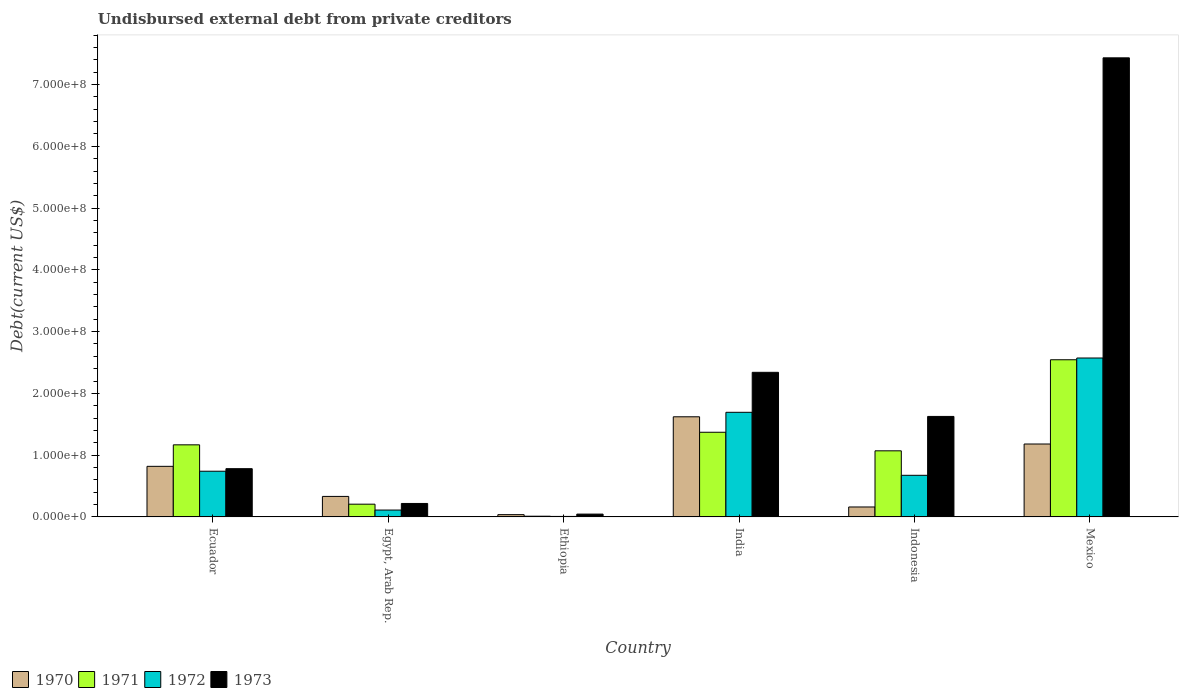How many different coloured bars are there?
Keep it short and to the point. 4. Are the number of bars per tick equal to the number of legend labels?
Your answer should be very brief. Yes. Are the number of bars on each tick of the X-axis equal?
Provide a short and direct response. Yes. How many bars are there on the 5th tick from the left?
Keep it short and to the point. 4. How many bars are there on the 2nd tick from the right?
Ensure brevity in your answer.  4. What is the label of the 2nd group of bars from the left?
Offer a terse response. Egypt, Arab Rep. What is the total debt in 1972 in Ecuador?
Ensure brevity in your answer.  7.40e+07. Across all countries, what is the maximum total debt in 1970?
Make the answer very short. 1.62e+08. Across all countries, what is the minimum total debt in 1970?
Offer a very short reply. 3.70e+06. In which country was the total debt in 1971 minimum?
Offer a terse response. Ethiopia. What is the total total debt in 1973 in the graph?
Offer a terse response. 1.24e+09. What is the difference between the total debt in 1970 in India and that in Mexico?
Your answer should be compact. 4.41e+07. What is the difference between the total debt in 1970 in Indonesia and the total debt in 1971 in Mexico?
Provide a short and direct response. -2.38e+08. What is the average total debt in 1970 per country?
Give a very brief answer. 6.92e+07. What is the difference between the total debt of/in 1972 and total debt of/in 1970 in Mexico?
Provide a succinct answer. 1.39e+08. In how many countries, is the total debt in 1973 greater than 320000000 US$?
Offer a terse response. 1. What is the ratio of the total debt in 1970 in Ecuador to that in India?
Provide a short and direct response. 0.51. Is the difference between the total debt in 1972 in Ethiopia and Mexico greater than the difference between the total debt in 1970 in Ethiopia and Mexico?
Your response must be concise. No. What is the difference between the highest and the second highest total debt in 1972?
Provide a short and direct response. 8.79e+07. What is the difference between the highest and the lowest total debt in 1973?
Ensure brevity in your answer.  7.39e+08. Is it the case that in every country, the sum of the total debt in 1972 and total debt in 1971 is greater than the sum of total debt in 1970 and total debt in 1973?
Give a very brief answer. No. What does the 3rd bar from the left in Ecuador represents?
Make the answer very short. 1972. How many bars are there?
Your answer should be very brief. 24. Are all the bars in the graph horizontal?
Ensure brevity in your answer.  No. How many countries are there in the graph?
Ensure brevity in your answer.  6. What is the difference between two consecutive major ticks on the Y-axis?
Offer a terse response. 1.00e+08. Are the values on the major ticks of Y-axis written in scientific E-notation?
Make the answer very short. Yes. What is the title of the graph?
Make the answer very short. Undisbursed external debt from private creditors. Does "1992" appear as one of the legend labels in the graph?
Provide a short and direct response. No. What is the label or title of the Y-axis?
Provide a succinct answer. Debt(current US$). What is the Debt(current US$) of 1970 in Ecuador?
Offer a very short reply. 8.19e+07. What is the Debt(current US$) of 1971 in Ecuador?
Make the answer very short. 1.17e+08. What is the Debt(current US$) in 1972 in Ecuador?
Give a very brief answer. 7.40e+07. What is the Debt(current US$) of 1973 in Ecuador?
Your answer should be very brief. 7.81e+07. What is the Debt(current US$) of 1970 in Egypt, Arab Rep.?
Provide a succinct answer. 3.32e+07. What is the Debt(current US$) of 1971 in Egypt, Arab Rep.?
Your answer should be very brief. 2.06e+07. What is the Debt(current US$) of 1972 in Egypt, Arab Rep.?
Make the answer very short. 1.11e+07. What is the Debt(current US$) of 1973 in Egypt, Arab Rep.?
Keep it short and to the point. 2.18e+07. What is the Debt(current US$) of 1970 in Ethiopia?
Your response must be concise. 3.70e+06. What is the Debt(current US$) of 1971 in Ethiopia?
Ensure brevity in your answer.  1.16e+06. What is the Debt(current US$) in 1972 in Ethiopia?
Ensure brevity in your answer.  8.20e+05. What is the Debt(current US$) in 1973 in Ethiopia?
Your response must be concise. 4.57e+06. What is the Debt(current US$) in 1970 in India?
Provide a succinct answer. 1.62e+08. What is the Debt(current US$) of 1971 in India?
Provide a short and direct response. 1.37e+08. What is the Debt(current US$) in 1972 in India?
Offer a terse response. 1.69e+08. What is the Debt(current US$) in 1973 in India?
Make the answer very short. 2.34e+08. What is the Debt(current US$) of 1970 in Indonesia?
Make the answer very short. 1.61e+07. What is the Debt(current US$) of 1971 in Indonesia?
Your answer should be compact. 1.07e+08. What is the Debt(current US$) of 1972 in Indonesia?
Ensure brevity in your answer.  6.74e+07. What is the Debt(current US$) of 1973 in Indonesia?
Give a very brief answer. 1.63e+08. What is the Debt(current US$) in 1970 in Mexico?
Ensure brevity in your answer.  1.18e+08. What is the Debt(current US$) in 1971 in Mexico?
Give a very brief answer. 2.54e+08. What is the Debt(current US$) in 1972 in Mexico?
Make the answer very short. 2.57e+08. What is the Debt(current US$) in 1973 in Mexico?
Provide a succinct answer. 7.43e+08. Across all countries, what is the maximum Debt(current US$) in 1970?
Provide a short and direct response. 1.62e+08. Across all countries, what is the maximum Debt(current US$) of 1971?
Your answer should be very brief. 2.54e+08. Across all countries, what is the maximum Debt(current US$) in 1972?
Your answer should be compact. 2.57e+08. Across all countries, what is the maximum Debt(current US$) in 1973?
Make the answer very short. 7.43e+08. Across all countries, what is the minimum Debt(current US$) in 1970?
Offer a terse response. 3.70e+06. Across all countries, what is the minimum Debt(current US$) of 1971?
Make the answer very short. 1.16e+06. Across all countries, what is the minimum Debt(current US$) of 1972?
Provide a succinct answer. 8.20e+05. Across all countries, what is the minimum Debt(current US$) in 1973?
Give a very brief answer. 4.57e+06. What is the total Debt(current US$) in 1970 in the graph?
Your response must be concise. 4.15e+08. What is the total Debt(current US$) of 1971 in the graph?
Offer a terse response. 6.37e+08. What is the total Debt(current US$) in 1972 in the graph?
Give a very brief answer. 5.80e+08. What is the total Debt(current US$) of 1973 in the graph?
Offer a very short reply. 1.24e+09. What is the difference between the Debt(current US$) of 1970 in Ecuador and that in Egypt, Arab Rep.?
Your response must be concise. 4.87e+07. What is the difference between the Debt(current US$) in 1971 in Ecuador and that in Egypt, Arab Rep.?
Give a very brief answer. 9.61e+07. What is the difference between the Debt(current US$) in 1972 in Ecuador and that in Egypt, Arab Rep.?
Offer a very short reply. 6.28e+07. What is the difference between the Debt(current US$) of 1973 in Ecuador and that in Egypt, Arab Rep.?
Your answer should be very brief. 5.63e+07. What is the difference between the Debt(current US$) of 1970 in Ecuador and that in Ethiopia?
Provide a short and direct response. 7.82e+07. What is the difference between the Debt(current US$) in 1971 in Ecuador and that in Ethiopia?
Ensure brevity in your answer.  1.16e+08. What is the difference between the Debt(current US$) of 1972 in Ecuador and that in Ethiopia?
Make the answer very short. 7.32e+07. What is the difference between the Debt(current US$) in 1973 in Ecuador and that in Ethiopia?
Ensure brevity in your answer.  7.35e+07. What is the difference between the Debt(current US$) in 1970 in Ecuador and that in India?
Offer a terse response. -8.02e+07. What is the difference between the Debt(current US$) in 1971 in Ecuador and that in India?
Keep it short and to the point. -2.03e+07. What is the difference between the Debt(current US$) in 1972 in Ecuador and that in India?
Provide a short and direct response. -9.54e+07. What is the difference between the Debt(current US$) in 1973 in Ecuador and that in India?
Offer a terse response. -1.56e+08. What is the difference between the Debt(current US$) of 1970 in Ecuador and that in Indonesia?
Make the answer very short. 6.58e+07. What is the difference between the Debt(current US$) in 1971 in Ecuador and that in Indonesia?
Ensure brevity in your answer.  9.70e+06. What is the difference between the Debt(current US$) of 1972 in Ecuador and that in Indonesia?
Provide a succinct answer. 6.60e+06. What is the difference between the Debt(current US$) in 1973 in Ecuador and that in Indonesia?
Your answer should be compact. -8.46e+07. What is the difference between the Debt(current US$) in 1970 in Ecuador and that in Mexico?
Your response must be concise. -3.62e+07. What is the difference between the Debt(current US$) in 1971 in Ecuador and that in Mexico?
Keep it short and to the point. -1.38e+08. What is the difference between the Debt(current US$) in 1972 in Ecuador and that in Mexico?
Ensure brevity in your answer.  -1.83e+08. What is the difference between the Debt(current US$) of 1973 in Ecuador and that in Mexico?
Keep it short and to the point. -6.65e+08. What is the difference between the Debt(current US$) of 1970 in Egypt, Arab Rep. and that in Ethiopia?
Offer a very short reply. 2.95e+07. What is the difference between the Debt(current US$) of 1971 in Egypt, Arab Rep. and that in Ethiopia?
Your answer should be compact. 1.95e+07. What is the difference between the Debt(current US$) of 1972 in Egypt, Arab Rep. and that in Ethiopia?
Your answer should be very brief. 1.03e+07. What is the difference between the Debt(current US$) of 1973 in Egypt, Arab Rep. and that in Ethiopia?
Make the answer very short. 1.72e+07. What is the difference between the Debt(current US$) of 1970 in Egypt, Arab Rep. and that in India?
Give a very brief answer. -1.29e+08. What is the difference between the Debt(current US$) in 1971 in Egypt, Arab Rep. and that in India?
Offer a very short reply. -1.16e+08. What is the difference between the Debt(current US$) in 1972 in Egypt, Arab Rep. and that in India?
Ensure brevity in your answer.  -1.58e+08. What is the difference between the Debt(current US$) of 1973 in Egypt, Arab Rep. and that in India?
Provide a succinct answer. -2.12e+08. What is the difference between the Debt(current US$) of 1970 in Egypt, Arab Rep. and that in Indonesia?
Ensure brevity in your answer.  1.71e+07. What is the difference between the Debt(current US$) in 1971 in Egypt, Arab Rep. and that in Indonesia?
Your response must be concise. -8.64e+07. What is the difference between the Debt(current US$) in 1972 in Egypt, Arab Rep. and that in Indonesia?
Ensure brevity in your answer.  -5.62e+07. What is the difference between the Debt(current US$) in 1973 in Egypt, Arab Rep. and that in Indonesia?
Your response must be concise. -1.41e+08. What is the difference between the Debt(current US$) in 1970 in Egypt, Arab Rep. and that in Mexico?
Give a very brief answer. -8.48e+07. What is the difference between the Debt(current US$) of 1971 in Egypt, Arab Rep. and that in Mexico?
Your answer should be very brief. -2.34e+08. What is the difference between the Debt(current US$) in 1972 in Egypt, Arab Rep. and that in Mexico?
Your answer should be compact. -2.46e+08. What is the difference between the Debt(current US$) in 1973 in Egypt, Arab Rep. and that in Mexico?
Provide a succinct answer. -7.21e+08. What is the difference between the Debt(current US$) in 1970 in Ethiopia and that in India?
Your answer should be compact. -1.58e+08. What is the difference between the Debt(current US$) of 1971 in Ethiopia and that in India?
Offer a terse response. -1.36e+08. What is the difference between the Debt(current US$) in 1972 in Ethiopia and that in India?
Your answer should be compact. -1.69e+08. What is the difference between the Debt(current US$) of 1973 in Ethiopia and that in India?
Provide a short and direct response. -2.30e+08. What is the difference between the Debt(current US$) in 1970 in Ethiopia and that in Indonesia?
Keep it short and to the point. -1.24e+07. What is the difference between the Debt(current US$) of 1971 in Ethiopia and that in Indonesia?
Your answer should be compact. -1.06e+08. What is the difference between the Debt(current US$) of 1972 in Ethiopia and that in Indonesia?
Keep it short and to the point. -6.66e+07. What is the difference between the Debt(current US$) of 1973 in Ethiopia and that in Indonesia?
Make the answer very short. -1.58e+08. What is the difference between the Debt(current US$) in 1970 in Ethiopia and that in Mexico?
Offer a terse response. -1.14e+08. What is the difference between the Debt(current US$) of 1971 in Ethiopia and that in Mexico?
Make the answer very short. -2.53e+08. What is the difference between the Debt(current US$) in 1972 in Ethiopia and that in Mexico?
Ensure brevity in your answer.  -2.56e+08. What is the difference between the Debt(current US$) in 1973 in Ethiopia and that in Mexico?
Make the answer very short. -7.39e+08. What is the difference between the Debt(current US$) in 1970 in India and that in Indonesia?
Offer a terse response. 1.46e+08. What is the difference between the Debt(current US$) in 1971 in India and that in Indonesia?
Your answer should be very brief. 3.00e+07. What is the difference between the Debt(current US$) of 1972 in India and that in Indonesia?
Provide a succinct answer. 1.02e+08. What is the difference between the Debt(current US$) of 1973 in India and that in Indonesia?
Your answer should be very brief. 7.14e+07. What is the difference between the Debt(current US$) of 1970 in India and that in Mexico?
Give a very brief answer. 4.41e+07. What is the difference between the Debt(current US$) of 1971 in India and that in Mexico?
Give a very brief answer. -1.17e+08. What is the difference between the Debt(current US$) in 1972 in India and that in Mexico?
Keep it short and to the point. -8.79e+07. What is the difference between the Debt(current US$) of 1973 in India and that in Mexico?
Offer a terse response. -5.09e+08. What is the difference between the Debt(current US$) in 1970 in Indonesia and that in Mexico?
Your response must be concise. -1.02e+08. What is the difference between the Debt(current US$) of 1971 in Indonesia and that in Mexico?
Provide a short and direct response. -1.47e+08. What is the difference between the Debt(current US$) in 1972 in Indonesia and that in Mexico?
Make the answer very short. -1.90e+08. What is the difference between the Debt(current US$) in 1973 in Indonesia and that in Mexico?
Provide a short and direct response. -5.81e+08. What is the difference between the Debt(current US$) in 1970 in Ecuador and the Debt(current US$) in 1971 in Egypt, Arab Rep.?
Provide a short and direct response. 6.13e+07. What is the difference between the Debt(current US$) of 1970 in Ecuador and the Debt(current US$) of 1972 in Egypt, Arab Rep.?
Provide a short and direct response. 7.08e+07. What is the difference between the Debt(current US$) in 1970 in Ecuador and the Debt(current US$) in 1973 in Egypt, Arab Rep.?
Provide a succinct answer. 6.01e+07. What is the difference between the Debt(current US$) of 1971 in Ecuador and the Debt(current US$) of 1972 in Egypt, Arab Rep.?
Keep it short and to the point. 1.06e+08. What is the difference between the Debt(current US$) of 1971 in Ecuador and the Debt(current US$) of 1973 in Egypt, Arab Rep.?
Give a very brief answer. 9.49e+07. What is the difference between the Debt(current US$) in 1972 in Ecuador and the Debt(current US$) in 1973 in Egypt, Arab Rep.?
Your answer should be compact. 5.22e+07. What is the difference between the Debt(current US$) in 1970 in Ecuador and the Debt(current US$) in 1971 in Ethiopia?
Offer a terse response. 8.07e+07. What is the difference between the Debt(current US$) of 1970 in Ecuador and the Debt(current US$) of 1972 in Ethiopia?
Offer a terse response. 8.11e+07. What is the difference between the Debt(current US$) of 1970 in Ecuador and the Debt(current US$) of 1973 in Ethiopia?
Provide a short and direct response. 7.73e+07. What is the difference between the Debt(current US$) of 1971 in Ecuador and the Debt(current US$) of 1972 in Ethiopia?
Make the answer very short. 1.16e+08. What is the difference between the Debt(current US$) of 1971 in Ecuador and the Debt(current US$) of 1973 in Ethiopia?
Provide a succinct answer. 1.12e+08. What is the difference between the Debt(current US$) in 1972 in Ecuador and the Debt(current US$) in 1973 in Ethiopia?
Provide a succinct answer. 6.94e+07. What is the difference between the Debt(current US$) in 1970 in Ecuador and the Debt(current US$) in 1971 in India?
Your response must be concise. -5.52e+07. What is the difference between the Debt(current US$) in 1970 in Ecuador and the Debt(current US$) in 1972 in India?
Provide a succinct answer. -8.75e+07. What is the difference between the Debt(current US$) in 1970 in Ecuador and the Debt(current US$) in 1973 in India?
Your response must be concise. -1.52e+08. What is the difference between the Debt(current US$) in 1971 in Ecuador and the Debt(current US$) in 1972 in India?
Provide a short and direct response. -5.27e+07. What is the difference between the Debt(current US$) of 1971 in Ecuador and the Debt(current US$) of 1973 in India?
Offer a very short reply. -1.17e+08. What is the difference between the Debt(current US$) of 1972 in Ecuador and the Debt(current US$) of 1973 in India?
Offer a very short reply. -1.60e+08. What is the difference between the Debt(current US$) in 1970 in Ecuador and the Debt(current US$) in 1971 in Indonesia?
Your answer should be compact. -2.51e+07. What is the difference between the Debt(current US$) of 1970 in Ecuador and the Debt(current US$) of 1972 in Indonesia?
Your answer should be very brief. 1.45e+07. What is the difference between the Debt(current US$) in 1970 in Ecuador and the Debt(current US$) in 1973 in Indonesia?
Give a very brief answer. -8.08e+07. What is the difference between the Debt(current US$) of 1971 in Ecuador and the Debt(current US$) of 1972 in Indonesia?
Keep it short and to the point. 4.93e+07. What is the difference between the Debt(current US$) of 1971 in Ecuador and the Debt(current US$) of 1973 in Indonesia?
Give a very brief answer. -4.60e+07. What is the difference between the Debt(current US$) in 1972 in Ecuador and the Debt(current US$) in 1973 in Indonesia?
Offer a terse response. -8.87e+07. What is the difference between the Debt(current US$) of 1970 in Ecuador and the Debt(current US$) of 1971 in Mexico?
Keep it short and to the point. -1.73e+08. What is the difference between the Debt(current US$) of 1970 in Ecuador and the Debt(current US$) of 1972 in Mexico?
Make the answer very short. -1.75e+08. What is the difference between the Debt(current US$) of 1970 in Ecuador and the Debt(current US$) of 1973 in Mexico?
Offer a terse response. -6.61e+08. What is the difference between the Debt(current US$) in 1971 in Ecuador and the Debt(current US$) in 1972 in Mexico?
Offer a very short reply. -1.41e+08. What is the difference between the Debt(current US$) of 1971 in Ecuador and the Debt(current US$) of 1973 in Mexico?
Provide a short and direct response. -6.27e+08. What is the difference between the Debt(current US$) of 1972 in Ecuador and the Debt(current US$) of 1973 in Mexico?
Give a very brief answer. -6.69e+08. What is the difference between the Debt(current US$) in 1970 in Egypt, Arab Rep. and the Debt(current US$) in 1971 in Ethiopia?
Offer a terse response. 3.21e+07. What is the difference between the Debt(current US$) of 1970 in Egypt, Arab Rep. and the Debt(current US$) of 1972 in Ethiopia?
Provide a succinct answer. 3.24e+07. What is the difference between the Debt(current US$) in 1970 in Egypt, Arab Rep. and the Debt(current US$) in 1973 in Ethiopia?
Keep it short and to the point. 2.87e+07. What is the difference between the Debt(current US$) in 1971 in Egypt, Arab Rep. and the Debt(current US$) in 1972 in Ethiopia?
Your response must be concise. 1.98e+07. What is the difference between the Debt(current US$) of 1971 in Egypt, Arab Rep. and the Debt(current US$) of 1973 in Ethiopia?
Offer a terse response. 1.61e+07. What is the difference between the Debt(current US$) in 1972 in Egypt, Arab Rep. and the Debt(current US$) in 1973 in Ethiopia?
Give a very brief answer. 6.56e+06. What is the difference between the Debt(current US$) of 1970 in Egypt, Arab Rep. and the Debt(current US$) of 1971 in India?
Your answer should be very brief. -1.04e+08. What is the difference between the Debt(current US$) in 1970 in Egypt, Arab Rep. and the Debt(current US$) in 1972 in India?
Your answer should be very brief. -1.36e+08. What is the difference between the Debt(current US$) in 1970 in Egypt, Arab Rep. and the Debt(current US$) in 1973 in India?
Give a very brief answer. -2.01e+08. What is the difference between the Debt(current US$) of 1971 in Egypt, Arab Rep. and the Debt(current US$) of 1972 in India?
Keep it short and to the point. -1.49e+08. What is the difference between the Debt(current US$) of 1971 in Egypt, Arab Rep. and the Debt(current US$) of 1973 in India?
Keep it short and to the point. -2.13e+08. What is the difference between the Debt(current US$) in 1972 in Egypt, Arab Rep. and the Debt(current US$) in 1973 in India?
Ensure brevity in your answer.  -2.23e+08. What is the difference between the Debt(current US$) of 1970 in Egypt, Arab Rep. and the Debt(current US$) of 1971 in Indonesia?
Your answer should be compact. -7.38e+07. What is the difference between the Debt(current US$) of 1970 in Egypt, Arab Rep. and the Debt(current US$) of 1972 in Indonesia?
Your response must be concise. -3.42e+07. What is the difference between the Debt(current US$) of 1970 in Egypt, Arab Rep. and the Debt(current US$) of 1973 in Indonesia?
Keep it short and to the point. -1.29e+08. What is the difference between the Debt(current US$) in 1971 in Egypt, Arab Rep. and the Debt(current US$) in 1972 in Indonesia?
Your answer should be compact. -4.67e+07. What is the difference between the Debt(current US$) in 1971 in Egypt, Arab Rep. and the Debt(current US$) in 1973 in Indonesia?
Keep it short and to the point. -1.42e+08. What is the difference between the Debt(current US$) of 1972 in Egypt, Arab Rep. and the Debt(current US$) of 1973 in Indonesia?
Keep it short and to the point. -1.52e+08. What is the difference between the Debt(current US$) in 1970 in Egypt, Arab Rep. and the Debt(current US$) in 1971 in Mexico?
Your response must be concise. -2.21e+08. What is the difference between the Debt(current US$) of 1970 in Egypt, Arab Rep. and the Debt(current US$) of 1972 in Mexico?
Provide a short and direct response. -2.24e+08. What is the difference between the Debt(current US$) of 1970 in Egypt, Arab Rep. and the Debt(current US$) of 1973 in Mexico?
Provide a short and direct response. -7.10e+08. What is the difference between the Debt(current US$) of 1971 in Egypt, Arab Rep. and the Debt(current US$) of 1972 in Mexico?
Make the answer very short. -2.37e+08. What is the difference between the Debt(current US$) in 1971 in Egypt, Arab Rep. and the Debt(current US$) in 1973 in Mexico?
Give a very brief answer. -7.23e+08. What is the difference between the Debt(current US$) of 1972 in Egypt, Arab Rep. and the Debt(current US$) of 1973 in Mexico?
Give a very brief answer. -7.32e+08. What is the difference between the Debt(current US$) of 1970 in Ethiopia and the Debt(current US$) of 1971 in India?
Provide a short and direct response. -1.33e+08. What is the difference between the Debt(current US$) of 1970 in Ethiopia and the Debt(current US$) of 1972 in India?
Make the answer very short. -1.66e+08. What is the difference between the Debt(current US$) of 1970 in Ethiopia and the Debt(current US$) of 1973 in India?
Offer a terse response. -2.30e+08. What is the difference between the Debt(current US$) of 1971 in Ethiopia and the Debt(current US$) of 1972 in India?
Give a very brief answer. -1.68e+08. What is the difference between the Debt(current US$) of 1971 in Ethiopia and the Debt(current US$) of 1973 in India?
Your answer should be compact. -2.33e+08. What is the difference between the Debt(current US$) of 1972 in Ethiopia and the Debt(current US$) of 1973 in India?
Make the answer very short. -2.33e+08. What is the difference between the Debt(current US$) of 1970 in Ethiopia and the Debt(current US$) of 1971 in Indonesia?
Give a very brief answer. -1.03e+08. What is the difference between the Debt(current US$) of 1970 in Ethiopia and the Debt(current US$) of 1972 in Indonesia?
Keep it short and to the point. -6.37e+07. What is the difference between the Debt(current US$) in 1970 in Ethiopia and the Debt(current US$) in 1973 in Indonesia?
Your answer should be very brief. -1.59e+08. What is the difference between the Debt(current US$) of 1971 in Ethiopia and the Debt(current US$) of 1972 in Indonesia?
Your answer should be compact. -6.62e+07. What is the difference between the Debt(current US$) of 1971 in Ethiopia and the Debt(current US$) of 1973 in Indonesia?
Ensure brevity in your answer.  -1.62e+08. What is the difference between the Debt(current US$) of 1972 in Ethiopia and the Debt(current US$) of 1973 in Indonesia?
Ensure brevity in your answer.  -1.62e+08. What is the difference between the Debt(current US$) of 1970 in Ethiopia and the Debt(current US$) of 1971 in Mexico?
Keep it short and to the point. -2.51e+08. What is the difference between the Debt(current US$) in 1970 in Ethiopia and the Debt(current US$) in 1972 in Mexico?
Offer a terse response. -2.54e+08. What is the difference between the Debt(current US$) in 1970 in Ethiopia and the Debt(current US$) in 1973 in Mexico?
Your answer should be very brief. -7.40e+08. What is the difference between the Debt(current US$) of 1971 in Ethiopia and the Debt(current US$) of 1972 in Mexico?
Ensure brevity in your answer.  -2.56e+08. What is the difference between the Debt(current US$) in 1971 in Ethiopia and the Debt(current US$) in 1973 in Mexico?
Make the answer very short. -7.42e+08. What is the difference between the Debt(current US$) of 1972 in Ethiopia and the Debt(current US$) of 1973 in Mexico?
Provide a succinct answer. -7.42e+08. What is the difference between the Debt(current US$) of 1970 in India and the Debt(current US$) of 1971 in Indonesia?
Provide a short and direct response. 5.51e+07. What is the difference between the Debt(current US$) of 1970 in India and the Debt(current US$) of 1972 in Indonesia?
Ensure brevity in your answer.  9.47e+07. What is the difference between the Debt(current US$) of 1970 in India and the Debt(current US$) of 1973 in Indonesia?
Offer a very short reply. -5.84e+05. What is the difference between the Debt(current US$) in 1971 in India and the Debt(current US$) in 1972 in Indonesia?
Offer a very short reply. 6.97e+07. What is the difference between the Debt(current US$) of 1971 in India and the Debt(current US$) of 1973 in Indonesia?
Make the answer very short. -2.56e+07. What is the difference between the Debt(current US$) in 1972 in India and the Debt(current US$) in 1973 in Indonesia?
Make the answer very short. 6.68e+06. What is the difference between the Debt(current US$) of 1970 in India and the Debt(current US$) of 1971 in Mexico?
Provide a succinct answer. -9.23e+07. What is the difference between the Debt(current US$) in 1970 in India and the Debt(current US$) in 1972 in Mexico?
Provide a short and direct response. -9.51e+07. What is the difference between the Debt(current US$) of 1970 in India and the Debt(current US$) of 1973 in Mexico?
Ensure brevity in your answer.  -5.81e+08. What is the difference between the Debt(current US$) of 1971 in India and the Debt(current US$) of 1972 in Mexico?
Provide a short and direct response. -1.20e+08. What is the difference between the Debt(current US$) of 1971 in India and the Debt(current US$) of 1973 in Mexico?
Your answer should be very brief. -6.06e+08. What is the difference between the Debt(current US$) in 1972 in India and the Debt(current US$) in 1973 in Mexico?
Your answer should be compact. -5.74e+08. What is the difference between the Debt(current US$) of 1970 in Indonesia and the Debt(current US$) of 1971 in Mexico?
Provide a succinct answer. -2.38e+08. What is the difference between the Debt(current US$) of 1970 in Indonesia and the Debt(current US$) of 1972 in Mexico?
Give a very brief answer. -2.41e+08. What is the difference between the Debt(current US$) of 1970 in Indonesia and the Debt(current US$) of 1973 in Mexico?
Offer a very short reply. -7.27e+08. What is the difference between the Debt(current US$) of 1971 in Indonesia and the Debt(current US$) of 1972 in Mexico?
Provide a succinct answer. -1.50e+08. What is the difference between the Debt(current US$) in 1971 in Indonesia and the Debt(current US$) in 1973 in Mexico?
Your response must be concise. -6.36e+08. What is the difference between the Debt(current US$) of 1972 in Indonesia and the Debt(current US$) of 1973 in Mexico?
Ensure brevity in your answer.  -6.76e+08. What is the average Debt(current US$) of 1970 per country?
Offer a very short reply. 6.92e+07. What is the average Debt(current US$) in 1971 per country?
Your answer should be very brief. 1.06e+08. What is the average Debt(current US$) of 1972 per country?
Offer a very short reply. 9.67e+07. What is the average Debt(current US$) of 1973 per country?
Give a very brief answer. 2.07e+08. What is the difference between the Debt(current US$) of 1970 and Debt(current US$) of 1971 in Ecuador?
Your response must be concise. -3.48e+07. What is the difference between the Debt(current US$) of 1970 and Debt(current US$) of 1972 in Ecuador?
Your response must be concise. 7.92e+06. What is the difference between the Debt(current US$) of 1970 and Debt(current US$) of 1973 in Ecuador?
Provide a short and direct response. 3.78e+06. What is the difference between the Debt(current US$) of 1971 and Debt(current US$) of 1972 in Ecuador?
Offer a very short reply. 4.27e+07. What is the difference between the Debt(current US$) of 1971 and Debt(current US$) of 1973 in Ecuador?
Your response must be concise. 3.86e+07. What is the difference between the Debt(current US$) in 1972 and Debt(current US$) in 1973 in Ecuador?
Make the answer very short. -4.14e+06. What is the difference between the Debt(current US$) in 1970 and Debt(current US$) in 1971 in Egypt, Arab Rep.?
Offer a very short reply. 1.26e+07. What is the difference between the Debt(current US$) of 1970 and Debt(current US$) of 1972 in Egypt, Arab Rep.?
Offer a terse response. 2.21e+07. What is the difference between the Debt(current US$) of 1970 and Debt(current US$) of 1973 in Egypt, Arab Rep.?
Offer a terse response. 1.14e+07. What is the difference between the Debt(current US$) in 1971 and Debt(current US$) in 1972 in Egypt, Arab Rep.?
Keep it short and to the point. 9.50e+06. What is the difference between the Debt(current US$) of 1971 and Debt(current US$) of 1973 in Egypt, Arab Rep.?
Keep it short and to the point. -1.17e+06. What is the difference between the Debt(current US$) of 1972 and Debt(current US$) of 1973 in Egypt, Arab Rep.?
Your answer should be compact. -1.07e+07. What is the difference between the Debt(current US$) in 1970 and Debt(current US$) in 1971 in Ethiopia?
Your answer should be very brief. 2.53e+06. What is the difference between the Debt(current US$) in 1970 and Debt(current US$) in 1972 in Ethiopia?
Provide a succinct answer. 2.88e+06. What is the difference between the Debt(current US$) in 1970 and Debt(current US$) in 1973 in Ethiopia?
Make the answer very short. -8.70e+05. What is the difference between the Debt(current US$) in 1971 and Debt(current US$) in 1972 in Ethiopia?
Your answer should be very brief. 3.45e+05. What is the difference between the Debt(current US$) in 1971 and Debt(current US$) in 1973 in Ethiopia?
Give a very brief answer. -3.40e+06. What is the difference between the Debt(current US$) of 1972 and Debt(current US$) of 1973 in Ethiopia?
Keep it short and to the point. -3.75e+06. What is the difference between the Debt(current US$) in 1970 and Debt(current US$) in 1971 in India?
Your answer should be very brief. 2.51e+07. What is the difference between the Debt(current US$) of 1970 and Debt(current US$) of 1972 in India?
Ensure brevity in your answer.  -7.26e+06. What is the difference between the Debt(current US$) of 1970 and Debt(current US$) of 1973 in India?
Ensure brevity in your answer.  -7.20e+07. What is the difference between the Debt(current US$) of 1971 and Debt(current US$) of 1972 in India?
Give a very brief answer. -3.23e+07. What is the difference between the Debt(current US$) in 1971 and Debt(current US$) in 1973 in India?
Your response must be concise. -9.70e+07. What is the difference between the Debt(current US$) of 1972 and Debt(current US$) of 1973 in India?
Ensure brevity in your answer.  -6.47e+07. What is the difference between the Debt(current US$) of 1970 and Debt(current US$) of 1971 in Indonesia?
Your response must be concise. -9.09e+07. What is the difference between the Debt(current US$) in 1970 and Debt(current US$) in 1972 in Indonesia?
Your response must be concise. -5.12e+07. What is the difference between the Debt(current US$) in 1970 and Debt(current US$) in 1973 in Indonesia?
Your response must be concise. -1.47e+08. What is the difference between the Debt(current US$) in 1971 and Debt(current US$) in 1972 in Indonesia?
Offer a very short reply. 3.96e+07. What is the difference between the Debt(current US$) of 1971 and Debt(current US$) of 1973 in Indonesia?
Provide a succinct answer. -5.57e+07. What is the difference between the Debt(current US$) of 1972 and Debt(current US$) of 1973 in Indonesia?
Your answer should be compact. -9.53e+07. What is the difference between the Debt(current US$) in 1970 and Debt(current US$) in 1971 in Mexico?
Offer a very short reply. -1.36e+08. What is the difference between the Debt(current US$) in 1970 and Debt(current US$) in 1972 in Mexico?
Keep it short and to the point. -1.39e+08. What is the difference between the Debt(current US$) in 1970 and Debt(current US$) in 1973 in Mexico?
Provide a short and direct response. -6.25e+08. What is the difference between the Debt(current US$) in 1971 and Debt(current US$) in 1972 in Mexico?
Your response must be concise. -2.84e+06. What is the difference between the Debt(current US$) in 1971 and Debt(current US$) in 1973 in Mexico?
Make the answer very short. -4.89e+08. What is the difference between the Debt(current US$) in 1972 and Debt(current US$) in 1973 in Mexico?
Your answer should be very brief. -4.86e+08. What is the ratio of the Debt(current US$) of 1970 in Ecuador to that in Egypt, Arab Rep.?
Your answer should be very brief. 2.47. What is the ratio of the Debt(current US$) in 1971 in Ecuador to that in Egypt, Arab Rep.?
Your response must be concise. 5.66. What is the ratio of the Debt(current US$) of 1972 in Ecuador to that in Egypt, Arab Rep.?
Offer a terse response. 6.65. What is the ratio of the Debt(current US$) in 1973 in Ecuador to that in Egypt, Arab Rep.?
Offer a terse response. 3.58. What is the ratio of the Debt(current US$) in 1970 in Ecuador to that in Ethiopia?
Offer a very short reply. 22.15. What is the ratio of the Debt(current US$) in 1971 in Ecuador to that in Ethiopia?
Offer a terse response. 100.19. What is the ratio of the Debt(current US$) of 1972 in Ecuador to that in Ethiopia?
Provide a short and direct response. 90.21. What is the ratio of the Debt(current US$) in 1973 in Ecuador to that in Ethiopia?
Offer a terse response. 17.1. What is the ratio of the Debt(current US$) in 1970 in Ecuador to that in India?
Offer a terse response. 0.51. What is the ratio of the Debt(current US$) in 1971 in Ecuador to that in India?
Make the answer very short. 0.85. What is the ratio of the Debt(current US$) of 1972 in Ecuador to that in India?
Give a very brief answer. 0.44. What is the ratio of the Debt(current US$) of 1973 in Ecuador to that in India?
Ensure brevity in your answer.  0.33. What is the ratio of the Debt(current US$) in 1970 in Ecuador to that in Indonesia?
Provide a succinct answer. 5.08. What is the ratio of the Debt(current US$) of 1971 in Ecuador to that in Indonesia?
Ensure brevity in your answer.  1.09. What is the ratio of the Debt(current US$) of 1972 in Ecuador to that in Indonesia?
Your answer should be very brief. 1.1. What is the ratio of the Debt(current US$) in 1973 in Ecuador to that in Indonesia?
Offer a terse response. 0.48. What is the ratio of the Debt(current US$) of 1970 in Ecuador to that in Mexico?
Offer a very short reply. 0.69. What is the ratio of the Debt(current US$) in 1971 in Ecuador to that in Mexico?
Offer a terse response. 0.46. What is the ratio of the Debt(current US$) in 1972 in Ecuador to that in Mexico?
Give a very brief answer. 0.29. What is the ratio of the Debt(current US$) of 1973 in Ecuador to that in Mexico?
Offer a very short reply. 0.11. What is the ratio of the Debt(current US$) in 1970 in Egypt, Arab Rep. to that in Ethiopia?
Make the answer very short. 8.99. What is the ratio of the Debt(current US$) in 1971 in Egypt, Arab Rep. to that in Ethiopia?
Give a very brief answer. 17.71. What is the ratio of the Debt(current US$) of 1972 in Egypt, Arab Rep. to that in Ethiopia?
Keep it short and to the point. 13.57. What is the ratio of the Debt(current US$) of 1973 in Egypt, Arab Rep. to that in Ethiopia?
Keep it short and to the point. 4.77. What is the ratio of the Debt(current US$) in 1970 in Egypt, Arab Rep. to that in India?
Offer a terse response. 0.2. What is the ratio of the Debt(current US$) in 1971 in Egypt, Arab Rep. to that in India?
Offer a very short reply. 0.15. What is the ratio of the Debt(current US$) in 1972 in Egypt, Arab Rep. to that in India?
Offer a very short reply. 0.07. What is the ratio of the Debt(current US$) of 1973 in Egypt, Arab Rep. to that in India?
Offer a terse response. 0.09. What is the ratio of the Debt(current US$) in 1970 in Egypt, Arab Rep. to that in Indonesia?
Offer a terse response. 2.06. What is the ratio of the Debt(current US$) of 1971 in Egypt, Arab Rep. to that in Indonesia?
Your response must be concise. 0.19. What is the ratio of the Debt(current US$) in 1972 in Egypt, Arab Rep. to that in Indonesia?
Ensure brevity in your answer.  0.17. What is the ratio of the Debt(current US$) in 1973 in Egypt, Arab Rep. to that in Indonesia?
Offer a very short reply. 0.13. What is the ratio of the Debt(current US$) of 1970 in Egypt, Arab Rep. to that in Mexico?
Keep it short and to the point. 0.28. What is the ratio of the Debt(current US$) of 1971 in Egypt, Arab Rep. to that in Mexico?
Provide a short and direct response. 0.08. What is the ratio of the Debt(current US$) in 1972 in Egypt, Arab Rep. to that in Mexico?
Ensure brevity in your answer.  0.04. What is the ratio of the Debt(current US$) of 1973 in Egypt, Arab Rep. to that in Mexico?
Offer a terse response. 0.03. What is the ratio of the Debt(current US$) in 1970 in Ethiopia to that in India?
Ensure brevity in your answer.  0.02. What is the ratio of the Debt(current US$) of 1971 in Ethiopia to that in India?
Offer a very short reply. 0.01. What is the ratio of the Debt(current US$) of 1972 in Ethiopia to that in India?
Give a very brief answer. 0. What is the ratio of the Debt(current US$) of 1973 in Ethiopia to that in India?
Offer a very short reply. 0.02. What is the ratio of the Debt(current US$) in 1970 in Ethiopia to that in Indonesia?
Make the answer very short. 0.23. What is the ratio of the Debt(current US$) of 1971 in Ethiopia to that in Indonesia?
Provide a succinct answer. 0.01. What is the ratio of the Debt(current US$) of 1972 in Ethiopia to that in Indonesia?
Ensure brevity in your answer.  0.01. What is the ratio of the Debt(current US$) in 1973 in Ethiopia to that in Indonesia?
Your answer should be very brief. 0.03. What is the ratio of the Debt(current US$) of 1970 in Ethiopia to that in Mexico?
Your answer should be compact. 0.03. What is the ratio of the Debt(current US$) in 1971 in Ethiopia to that in Mexico?
Offer a very short reply. 0. What is the ratio of the Debt(current US$) of 1972 in Ethiopia to that in Mexico?
Your answer should be compact. 0. What is the ratio of the Debt(current US$) in 1973 in Ethiopia to that in Mexico?
Keep it short and to the point. 0.01. What is the ratio of the Debt(current US$) in 1970 in India to that in Indonesia?
Give a very brief answer. 10.05. What is the ratio of the Debt(current US$) of 1971 in India to that in Indonesia?
Your answer should be compact. 1.28. What is the ratio of the Debt(current US$) in 1972 in India to that in Indonesia?
Give a very brief answer. 2.51. What is the ratio of the Debt(current US$) in 1973 in India to that in Indonesia?
Make the answer very short. 1.44. What is the ratio of the Debt(current US$) of 1970 in India to that in Mexico?
Make the answer very short. 1.37. What is the ratio of the Debt(current US$) in 1971 in India to that in Mexico?
Give a very brief answer. 0.54. What is the ratio of the Debt(current US$) in 1972 in India to that in Mexico?
Keep it short and to the point. 0.66. What is the ratio of the Debt(current US$) of 1973 in India to that in Mexico?
Offer a very short reply. 0.32. What is the ratio of the Debt(current US$) of 1970 in Indonesia to that in Mexico?
Your answer should be very brief. 0.14. What is the ratio of the Debt(current US$) in 1971 in Indonesia to that in Mexico?
Make the answer very short. 0.42. What is the ratio of the Debt(current US$) of 1972 in Indonesia to that in Mexico?
Your answer should be compact. 0.26. What is the ratio of the Debt(current US$) in 1973 in Indonesia to that in Mexico?
Make the answer very short. 0.22. What is the difference between the highest and the second highest Debt(current US$) of 1970?
Your answer should be very brief. 4.41e+07. What is the difference between the highest and the second highest Debt(current US$) in 1971?
Provide a short and direct response. 1.17e+08. What is the difference between the highest and the second highest Debt(current US$) in 1972?
Your answer should be compact. 8.79e+07. What is the difference between the highest and the second highest Debt(current US$) in 1973?
Offer a very short reply. 5.09e+08. What is the difference between the highest and the lowest Debt(current US$) of 1970?
Your response must be concise. 1.58e+08. What is the difference between the highest and the lowest Debt(current US$) of 1971?
Make the answer very short. 2.53e+08. What is the difference between the highest and the lowest Debt(current US$) in 1972?
Your answer should be very brief. 2.56e+08. What is the difference between the highest and the lowest Debt(current US$) of 1973?
Provide a succinct answer. 7.39e+08. 